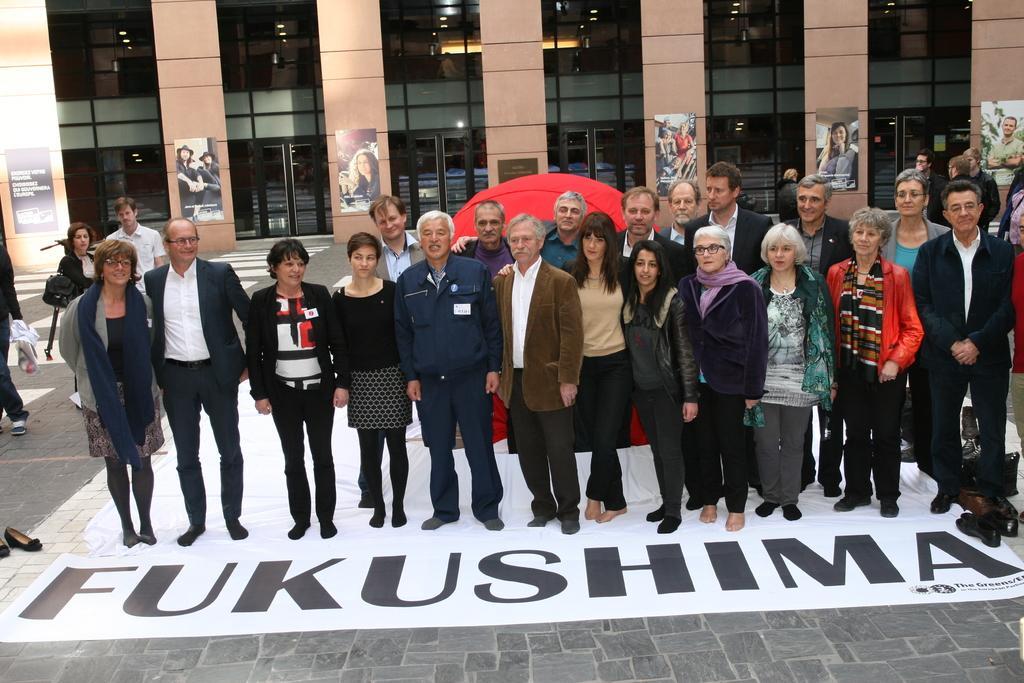Could you give a brief overview of what you see in this image? In this image there are group of people standing on the floor, Behind them there is a red color cloth. In the background there is a building. There are few wall posters stick to the pillars of the building. 